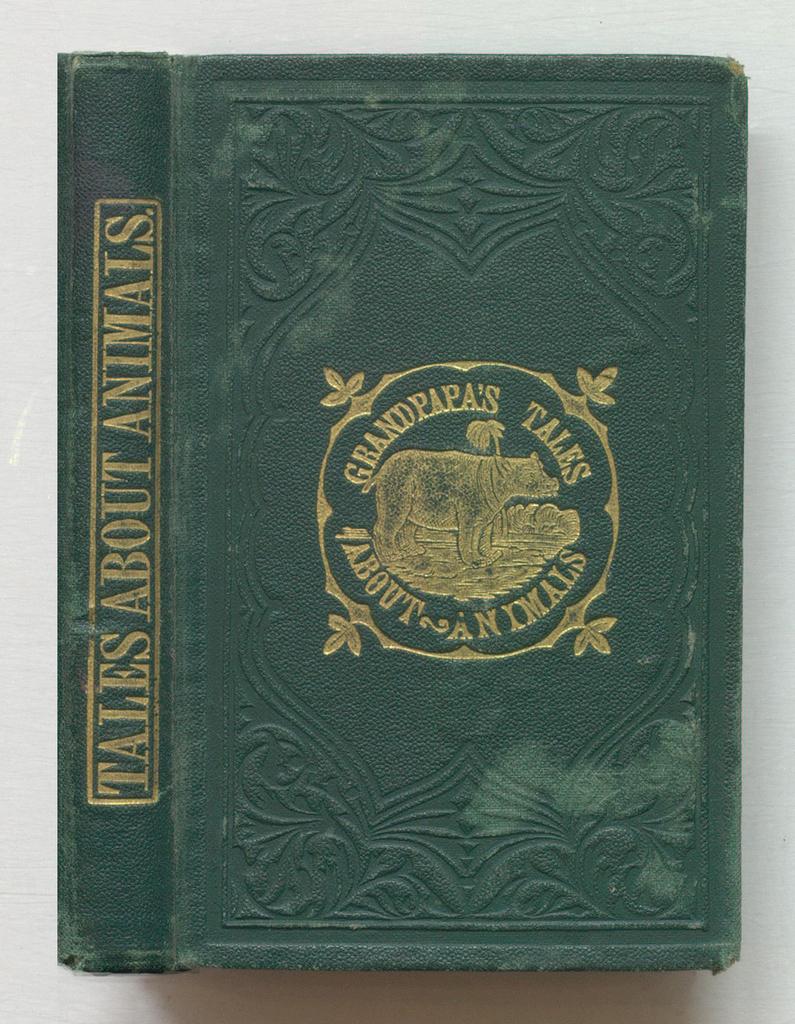What is on the spine of the book?
Provide a succinct answer. Tales about animals. What is the title of the book?
Your answer should be very brief. Tales about animals. 